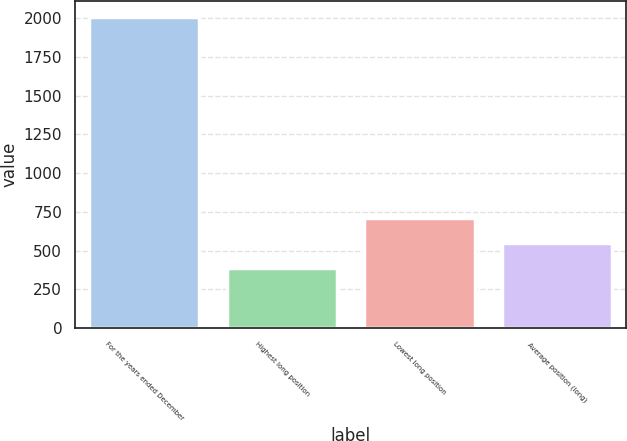Convert chart. <chart><loc_0><loc_0><loc_500><loc_500><bar_chart><fcel>For the years ended December<fcel>Highest long position<fcel>Lowest long position<fcel>Average position (long)<nl><fcel>2010<fcel>386.2<fcel>710.96<fcel>548.58<nl></chart> 